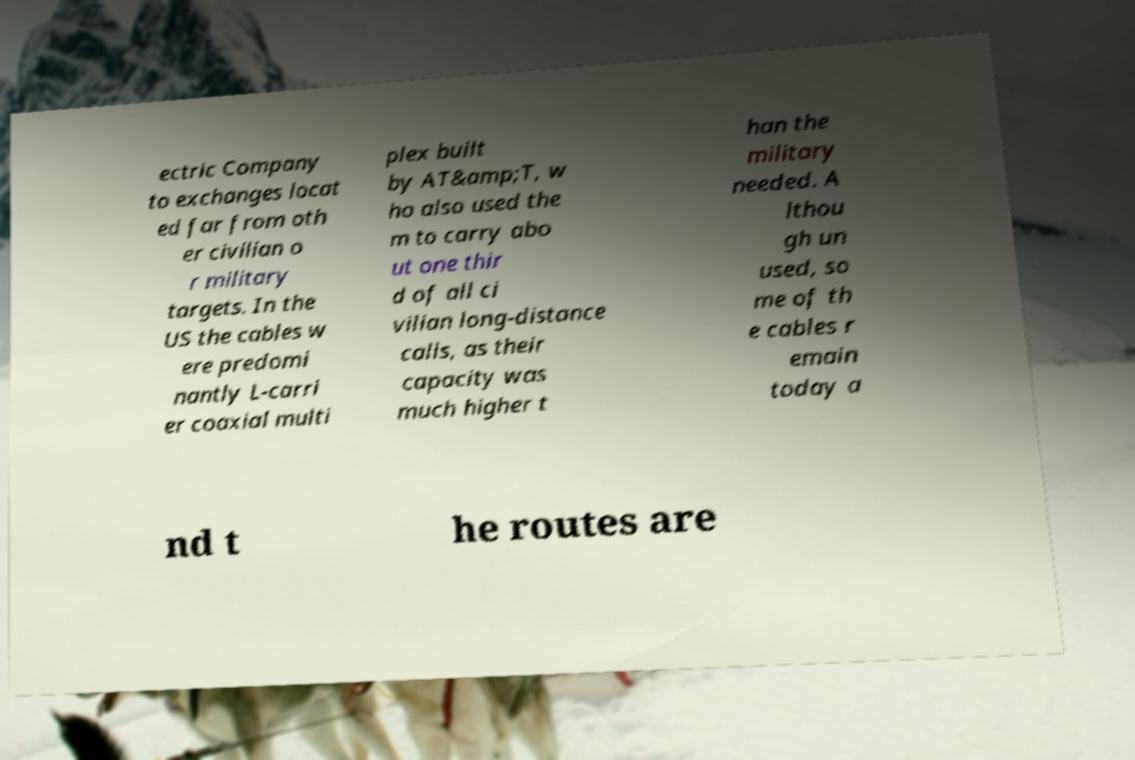There's text embedded in this image that I need extracted. Can you transcribe it verbatim? ectric Company to exchanges locat ed far from oth er civilian o r military targets. In the US the cables w ere predomi nantly L-carri er coaxial multi plex built by AT&amp;T, w ho also used the m to carry abo ut one thir d of all ci vilian long-distance calls, as their capacity was much higher t han the military needed. A lthou gh un used, so me of th e cables r emain today a nd t he routes are 